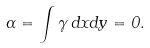Convert formula to latex. <formula><loc_0><loc_0><loc_500><loc_500>\Gamma = \int { \gamma \, d x d y } = 0 .</formula> 